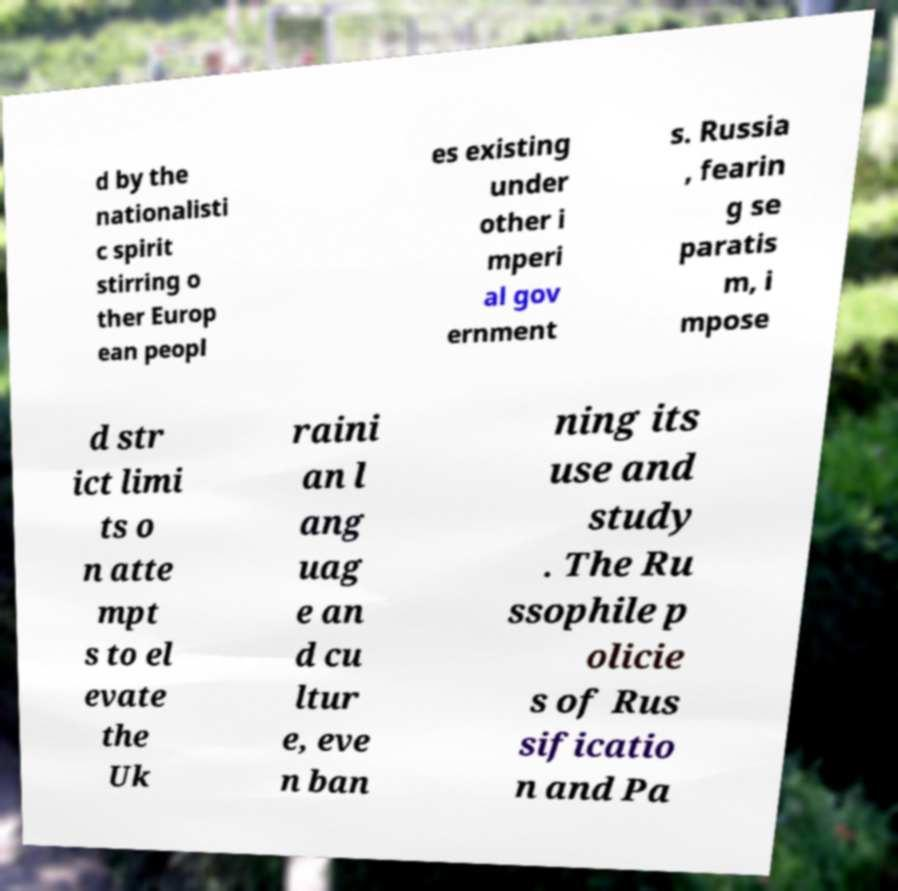For documentation purposes, I need the text within this image transcribed. Could you provide that? d by the nationalisti c spirit stirring o ther Europ ean peopl es existing under other i mperi al gov ernment s. Russia , fearin g se paratis m, i mpose d str ict limi ts o n atte mpt s to el evate the Uk raini an l ang uag e an d cu ltur e, eve n ban ning its use and study . The Ru ssophile p olicie s of Rus sificatio n and Pa 